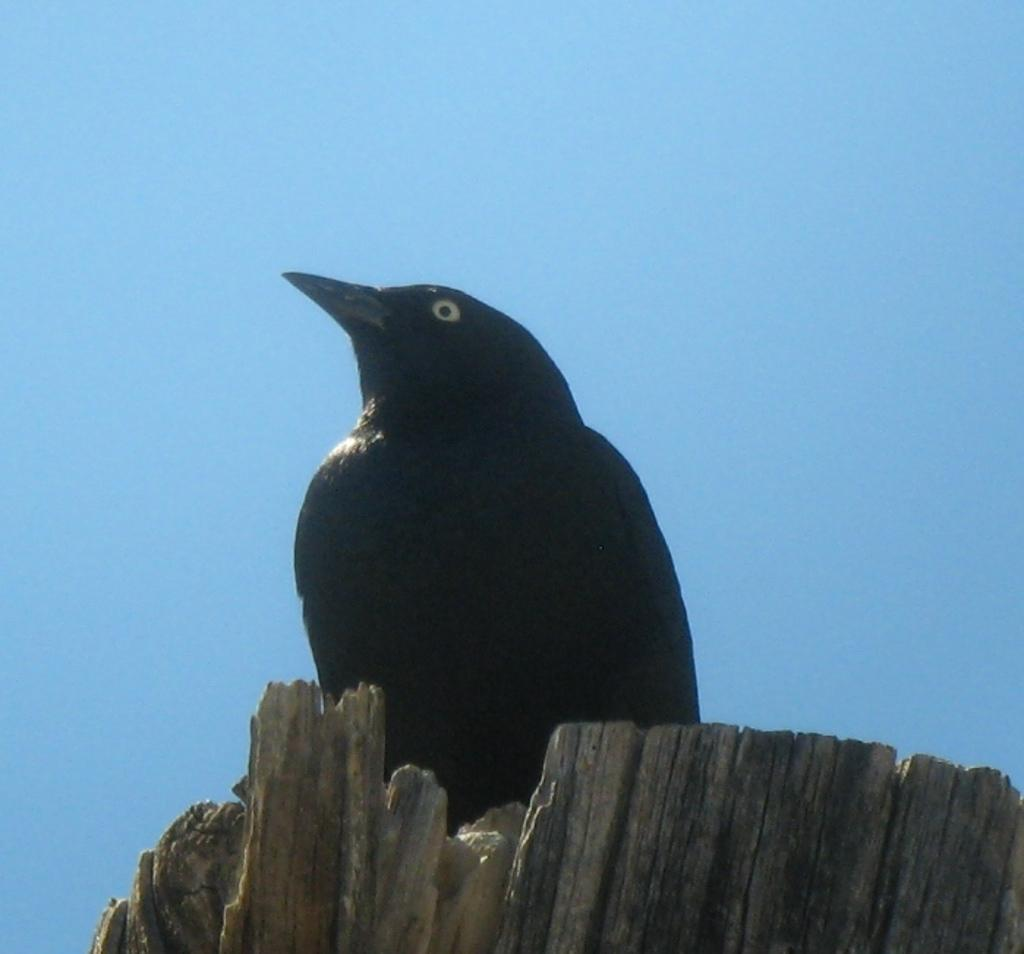What type of animal is in the image? There is a bird in the image. What color is the bird? The bird is black in color. Where is the bird located? The bird is on a tree pole. What can be seen in the background of the image? The sky is visible in the background of the image. What is the condition of the sky in the image? The sky is clear in the image. What type of hat is the bird wearing in the image? There is no hat present in the image; the bird is not wearing any clothing. 